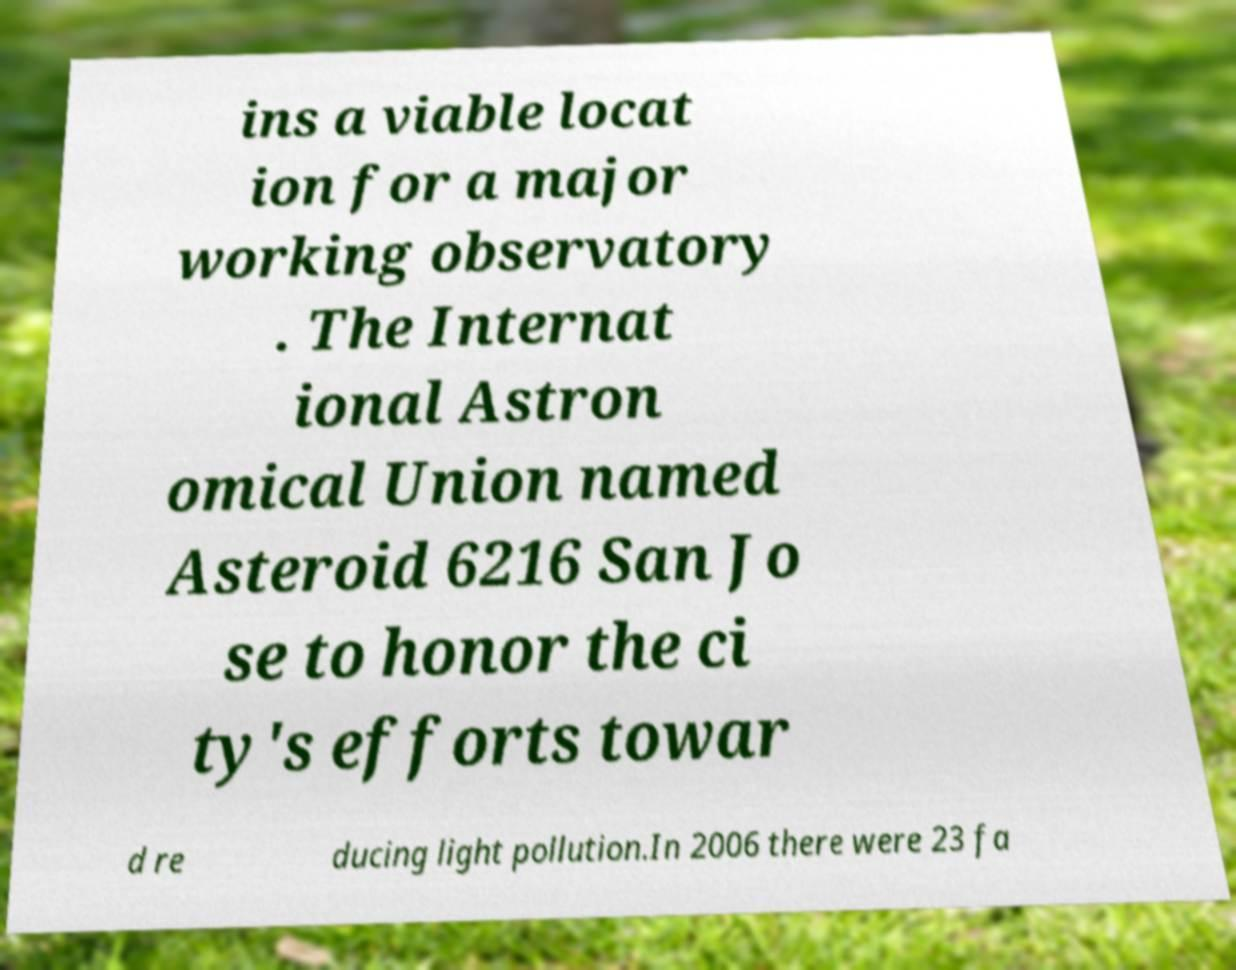Can you accurately transcribe the text from the provided image for me? ins a viable locat ion for a major working observatory . The Internat ional Astron omical Union named Asteroid 6216 San Jo se to honor the ci ty's efforts towar d re ducing light pollution.In 2006 there were 23 fa 